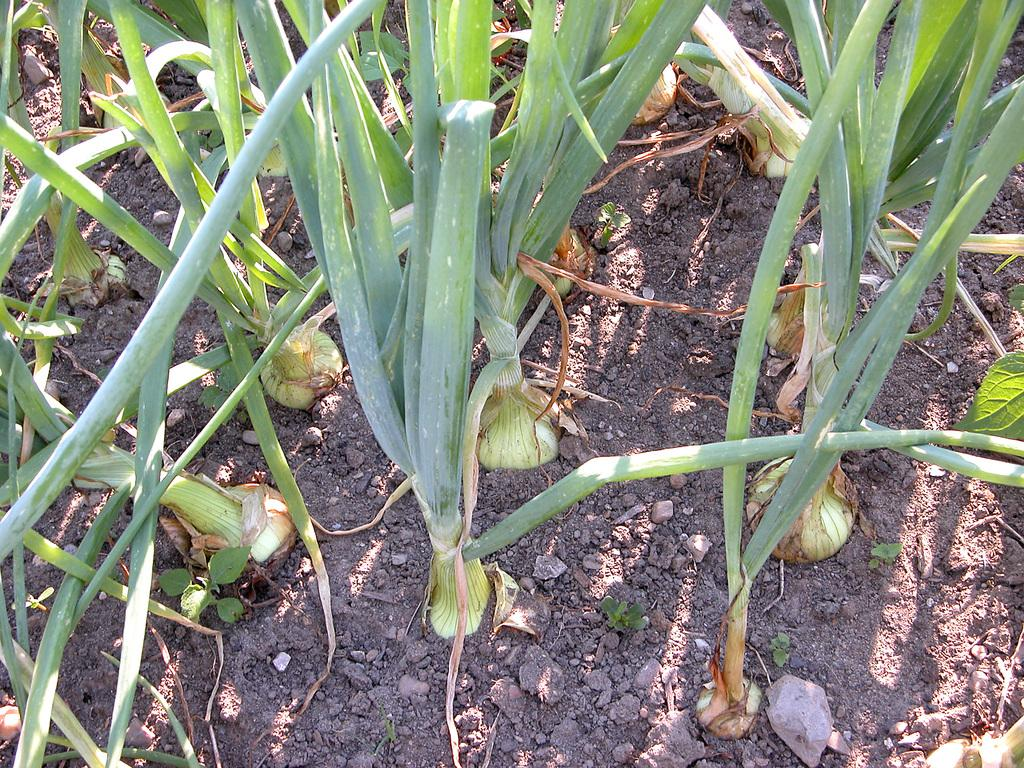What type of living organisms can be seen in the image? Plants can be seen in the image. What type of cloud can be seen floating above the sea in the image? There is no cloud or sea present in the image; it only features plants. 